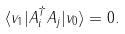<formula> <loc_0><loc_0><loc_500><loc_500>\langle v _ { 1 } | A _ { i } ^ { \dagger } A _ { j } | v _ { 0 } \rangle = 0 .</formula> 